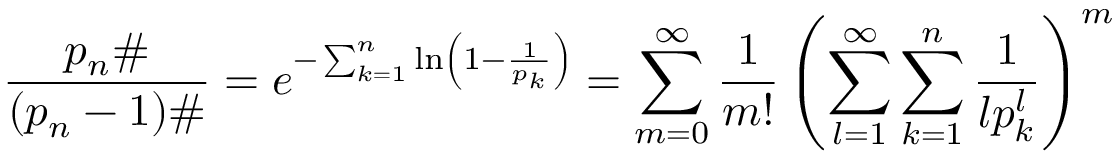<formula> <loc_0><loc_0><loc_500><loc_500>{ \frac { p _ { n } \# } { ( p _ { n } - 1 ) \# } } = e ^ { - \sum _ { k = 1 } ^ { n } \ln \left ( 1 - { \frac { 1 } { p _ { k } } } \right ) } = \sum _ { m = 0 } ^ { \infty } { \frac { 1 } { m ! } } \left ( \sum _ { l = 1 } ^ { \infty } \sum _ { k = 1 } ^ { n } { \frac { 1 } { l p _ { k } ^ { l } } } \right ) ^ { m }</formula> 